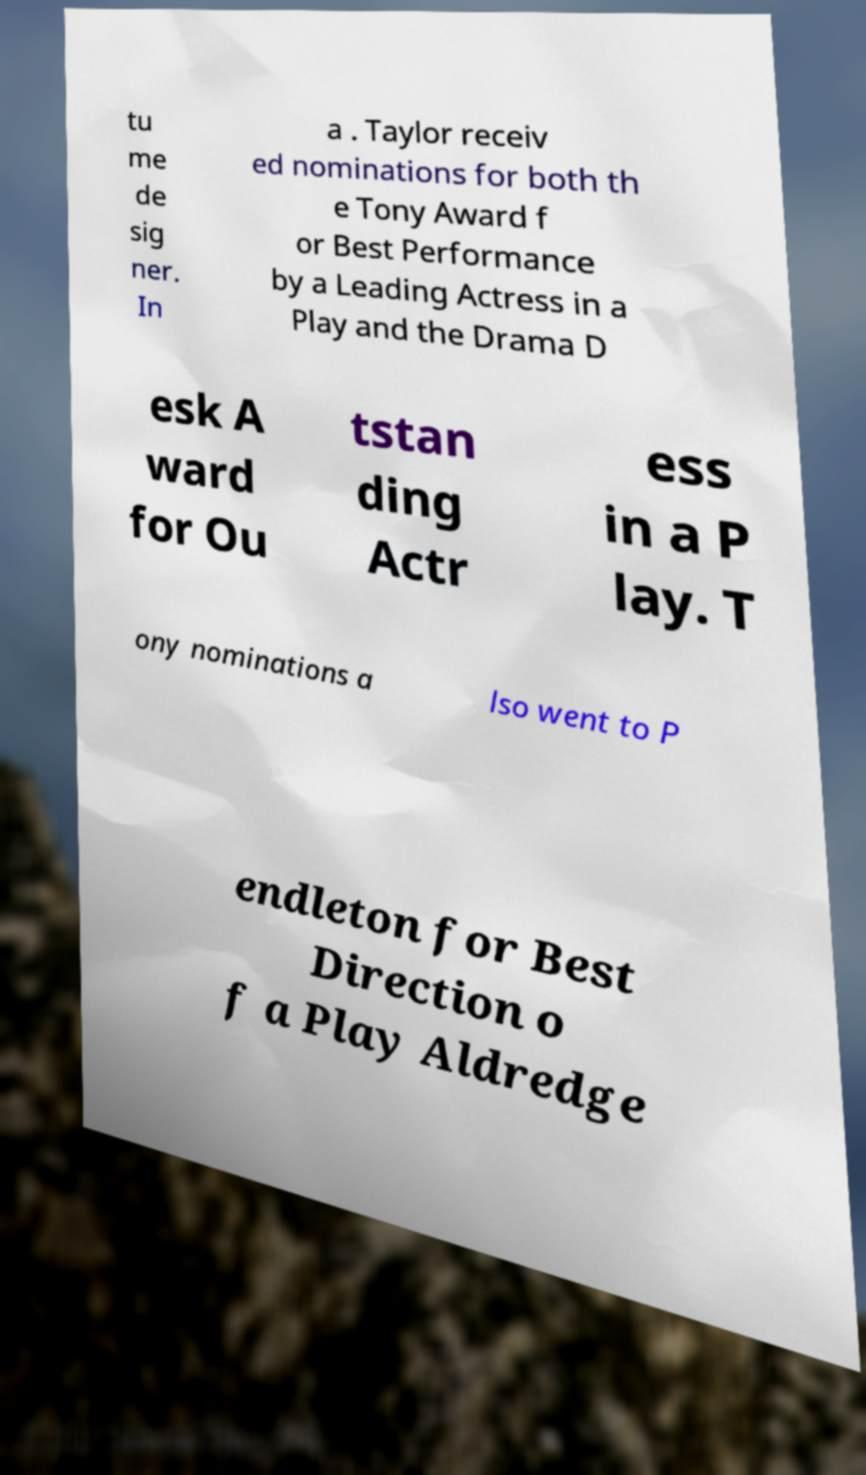For documentation purposes, I need the text within this image transcribed. Could you provide that? tu me de sig ner. In a . Taylor receiv ed nominations for both th e Tony Award f or Best Performance by a Leading Actress in a Play and the Drama D esk A ward for Ou tstan ding Actr ess in a P lay. T ony nominations a lso went to P endleton for Best Direction o f a Play Aldredge 